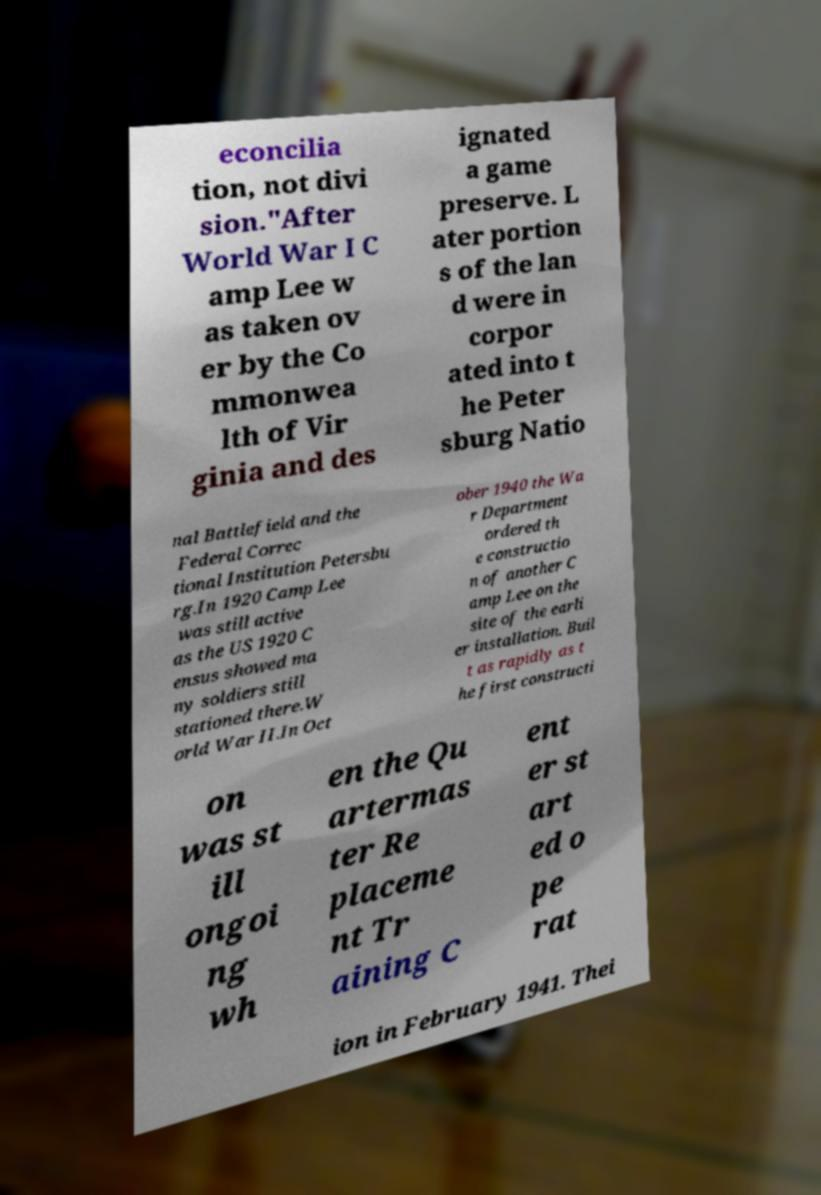For documentation purposes, I need the text within this image transcribed. Could you provide that? econcilia tion, not divi sion."After World War I C amp Lee w as taken ov er by the Co mmonwea lth of Vir ginia and des ignated a game preserve. L ater portion s of the lan d were in corpor ated into t he Peter sburg Natio nal Battlefield and the Federal Correc tional Institution Petersbu rg.In 1920 Camp Lee was still active as the US 1920 C ensus showed ma ny soldiers still stationed there.W orld War II.In Oct ober 1940 the Wa r Department ordered th e constructio n of another C amp Lee on the site of the earli er installation. Buil t as rapidly as t he first constructi on was st ill ongoi ng wh en the Qu artermas ter Re placeme nt Tr aining C ent er st art ed o pe rat ion in February 1941. Thei 